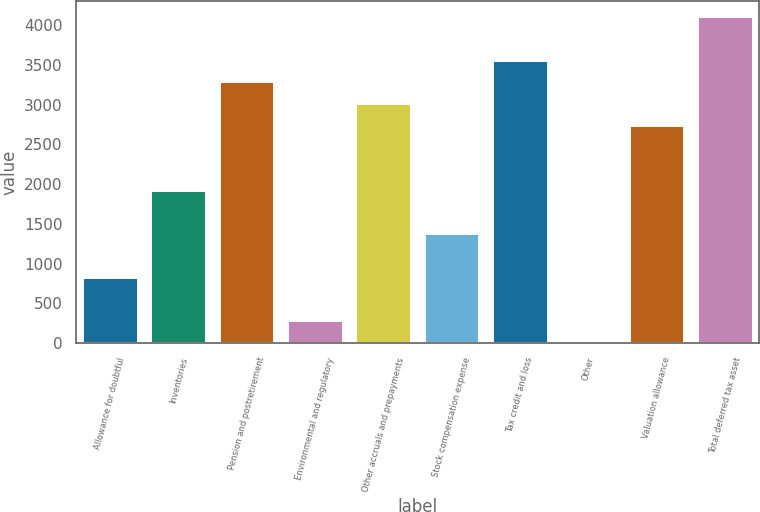<chart> <loc_0><loc_0><loc_500><loc_500><bar_chart><fcel>Allowance for doubtful<fcel>Inventories<fcel>Pension and postretirement<fcel>Environmental and regulatory<fcel>Other accruals and prepayments<fcel>Stock compensation expense<fcel>Tax credit and loss<fcel>Other<fcel>Valuation allowance<fcel>Total deferred tax asset<nl><fcel>822.13<fcel>1914.57<fcel>3280.12<fcel>275.91<fcel>3007.01<fcel>1368.35<fcel>3553.23<fcel>2.8<fcel>2733.9<fcel>4099.45<nl></chart> 